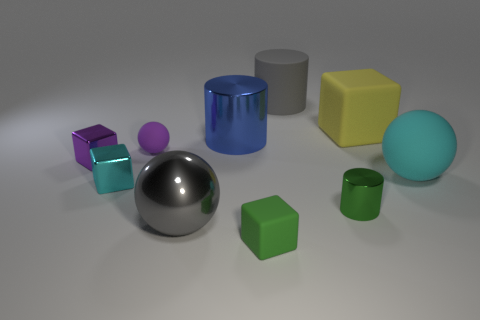Subtract all cylinders. How many objects are left? 7 Subtract all tiny green metal things. Subtract all big gray metallic things. How many objects are left? 8 Add 4 small green matte cubes. How many small green matte cubes are left? 5 Add 4 small yellow metallic cylinders. How many small yellow metallic cylinders exist? 4 Subtract 0 red blocks. How many objects are left? 10 